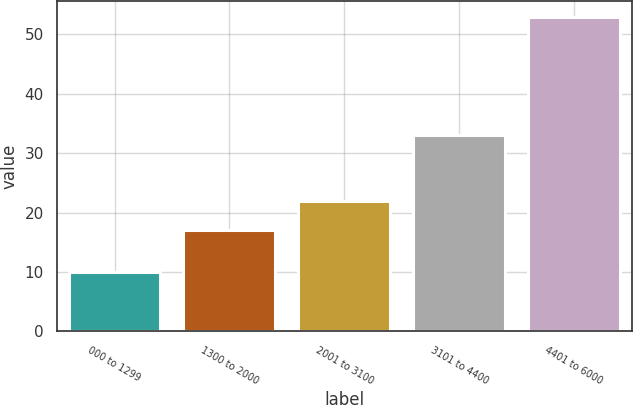Convert chart. <chart><loc_0><loc_0><loc_500><loc_500><bar_chart><fcel>000 to 1299<fcel>1300 to 2000<fcel>2001 to 3100<fcel>3101 to 4400<fcel>4401 to 6000<nl><fcel>10<fcel>17<fcel>22<fcel>33<fcel>53<nl></chart> 